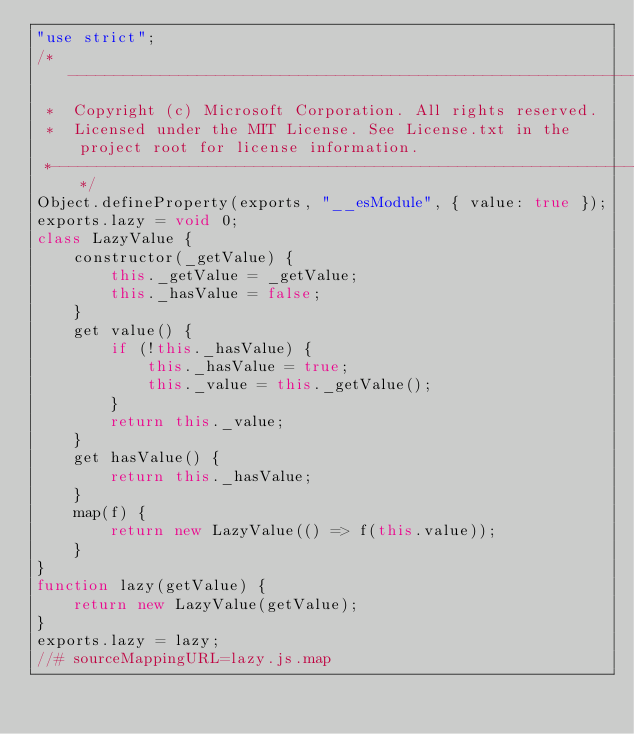Convert code to text. <code><loc_0><loc_0><loc_500><loc_500><_JavaScript_>"use strict";
/*---------------------------------------------------------------------------------------------
 *  Copyright (c) Microsoft Corporation. All rights reserved.
 *  Licensed under the MIT License. See License.txt in the project root for license information.
 *--------------------------------------------------------------------------------------------*/
Object.defineProperty(exports, "__esModule", { value: true });
exports.lazy = void 0;
class LazyValue {
    constructor(_getValue) {
        this._getValue = _getValue;
        this._hasValue = false;
    }
    get value() {
        if (!this._hasValue) {
            this._hasValue = true;
            this._value = this._getValue();
        }
        return this._value;
    }
    get hasValue() {
        return this._hasValue;
    }
    map(f) {
        return new LazyValue(() => f(this.value));
    }
}
function lazy(getValue) {
    return new LazyValue(getValue);
}
exports.lazy = lazy;
//# sourceMappingURL=lazy.js.map</code> 